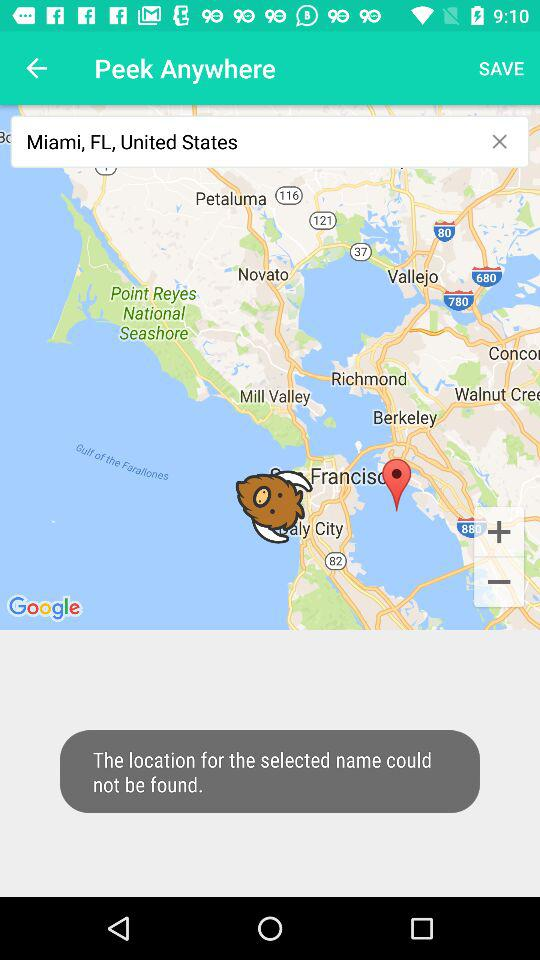When was the map first copyrighted?
When the provided information is insufficient, respond with <no answer>. <no answer> 